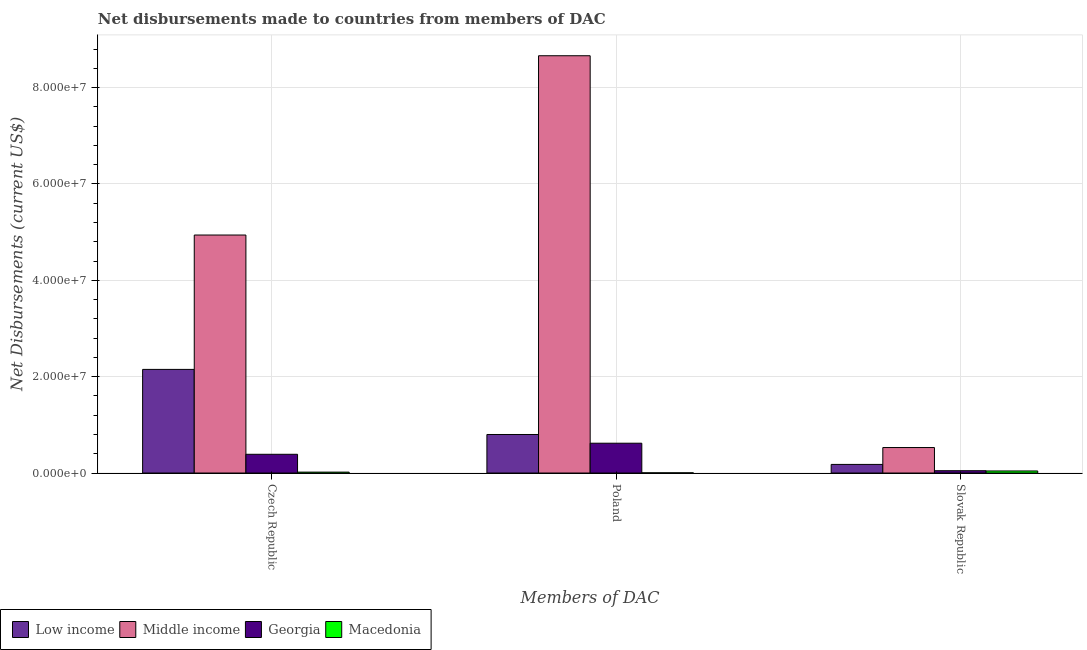How many different coloured bars are there?
Provide a succinct answer. 4. How many groups of bars are there?
Make the answer very short. 3. Are the number of bars per tick equal to the number of legend labels?
Provide a short and direct response. Yes. How many bars are there on the 2nd tick from the right?
Your answer should be compact. 4. What is the label of the 2nd group of bars from the left?
Offer a very short reply. Poland. What is the net disbursements made by poland in Low income?
Offer a very short reply. 8.00e+06. Across all countries, what is the maximum net disbursements made by slovak republic?
Offer a very short reply. 5.29e+06. Across all countries, what is the minimum net disbursements made by slovak republic?
Offer a terse response. 4.30e+05. In which country was the net disbursements made by czech republic maximum?
Offer a very short reply. Middle income. In which country was the net disbursements made by czech republic minimum?
Offer a very short reply. Macedonia. What is the total net disbursements made by slovak republic in the graph?
Keep it short and to the point. 7.99e+06. What is the difference between the net disbursements made by czech republic in Middle income and that in Low income?
Provide a short and direct response. 2.79e+07. What is the difference between the net disbursements made by czech republic in Low income and the net disbursements made by slovak republic in Georgia?
Your answer should be very brief. 2.10e+07. What is the average net disbursements made by slovak republic per country?
Ensure brevity in your answer.  2.00e+06. What is the difference between the net disbursements made by poland and net disbursements made by czech republic in Low income?
Your response must be concise. -1.35e+07. What is the ratio of the net disbursements made by poland in Low income to that in Middle income?
Your answer should be compact. 0.09. Is the net disbursements made by czech republic in Middle income less than that in Macedonia?
Ensure brevity in your answer.  No. Is the difference between the net disbursements made by poland in Middle income and Macedonia greater than the difference between the net disbursements made by czech republic in Middle income and Macedonia?
Offer a very short reply. Yes. What is the difference between the highest and the second highest net disbursements made by slovak republic?
Keep it short and to the point. 3.50e+06. What is the difference between the highest and the lowest net disbursements made by slovak republic?
Offer a terse response. 4.86e+06. In how many countries, is the net disbursements made by slovak republic greater than the average net disbursements made by slovak republic taken over all countries?
Your answer should be compact. 1. Is the sum of the net disbursements made by poland in Middle income and Macedonia greater than the maximum net disbursements made by czech republic across all countries?
Offer a very short reply. Yes. What does the 4th bar from the left in Czech Republic represents?
Keep it short and to the point. Macedonia. What does the 3rd bar from the right in Poland represents?
Offer a terse response. Middle income. What is the difference between two consecutive major ticks on the Y-axis?
Your response must be concise. 2.00e+07. Are the values on the major ticks of Y-axis written in scientific E-notation?
Your response must be concise. Yes. Does the graph contain grids?
Make the answer very short. Yes. How are the legend labels stacked?
Your response must be concise. Horizontal. What is the title of the graph?
Keep it short and to the point. Net disbursements made to countries from members of DAC. Does "Lao PDR" appear as one of the legend labels in the graph?
Ensure brevity in your answer.  No. What is the label or title of the X-axis?
Make the answer very short. Members of DAC. What is the label or title of the Y-axis?
Make the answer very short. Net Disbursements (current US$). What is the Net Disbursements (current US$) in Low income in Czech Republic?
Make the answer very short. 2.15e+07. What is the Net Disbursements (current US$) in Middle income in Czech Republic?
Offer a terse response. 4.94e+07. What is the Net Disbursements (current US$) in Georgia in Czech Republic?
Give a very brief answer. 3.89e+06. What is the Net Disbursements (current US$) of Macedonia in Czech Republic?
Give a very brief answer. 1.90e+05. What is the Net Disbursements (current US$) in Middle income in Poland?
Your response must be concise. 8.66e+07. What is the Net Disbursements (current US$) of Georgia in Poland?
Your answer should be very brief. 6.19e+06. What is the Net Disbursements (current US$) of Low income in Slovak Republic?
Give a very brief answer. 1.79e+06. What is the Net Disbursements (current US$) of Middle income in Slovak Republic?
Offer a very short reply. 5.29e+06. Across all Members of DAC, what is the maximum Net Disbursements (current US$) of Low income?
Offer a very short reply. 2.15e+07. Across all Members of DAC, what is the maximum Net Disbursements (current US$) in Middle income?
Keep it short and to the point. 8.66e+07. Across all Members of DAC, what is the maximum Net Disbursements (current US$) of Georgia?
Provide a succinct answer. 6.19e+06. Across all Members of DAC, what is the minimum Net Disbursements (current US$) of Low income?
Your response must be concise. 1.79e+06. Across all Members of DAC, what is the minimum Net Disbursements (current US$) in Middle income?
Your response must be concise. 5.29e+06. What is the total Net Disbursements (current US$) in Low income in the graph?
Offer a terse response. 3.13e+07. What is the total Net Disbursements (current US$) of Middle income in the graph?
Keep it short and to the point. 1.41e+08. What is the total Net Disbursements (current US$) of Georgia in the graph?
Keep it short and to the point. 1.06e+07. What is the difference between the Net Disbursements (current US$) in Low income in Czech Republic and that in Poland?
Offer a very short reply. 1.35e+07. What is the difference between the Net Disbursements (current US$) in Middle income in Czech Republic and that in Poland?
Ensure brevity in your answer.  -3.72e+07. What is the difference between the Net Disbursements (current US$) of Georgia in Czech Republic and that in Poland?
Offer a terse response. -2.30e+06. What is the difference between the Net Disbursements (current US$) in Macedonia in Czech Republic and that in Poland?
Your response must be concise. 1.50e+05. What is the difference between the Net Disbursements (current US$) of Low income in Czech Republic and that in Slovak Republic?
Your answer should be compact. 1.97e+07. What is the difference between the Net Disbursements (current US$) of Middle income in Czech Republic and that in Slovak Republic?
Ensure brevity in your answer.  4.41e+07. What is the difference between the Net Disbursements (current US$) in Georgia in Czech Republic and that in Slovak Republic?
Your answer should be compact. 3.41e+06. What is the difference between the Net Disbursements (current US$) in Macedonia in Czech Republic and that in Slovak Republic?
Provide a short and direct response. -2.40e+05. What is the difference between the Net Disbursements (current US$) in Low income in Poland and that in Slovak Republic?
Provide a short and direct response. 6.21e+06. What is the difference between the Net Disbursements (current US$) of Middle income in Poland and that in Slovak Republic?
Offer a very short reply. 8.13e+07. What is the difference between the Net Disbursements (current US$) of Georgia in Poland and that in Slovak Republic?
Give a very brief answer. 5.71e+06. What is the difference between the Net Disbursements (current US$) of Macedonia in Poland and that in Slovak Republic?
Give a very brief answer. -3.90e+05. What is the difference between the Net Disbursements (current US$) of Low income in Czech Republic and the Net Disbursements (current US$) of Middle income in Poland?
Offer a very short reply. -6.51e+07. What is the difference between the Net Disbursements (current US$) in Low income in Czech Republic and the Net Disbursements (current US$) in Georgia in Poland?
Give a very brief answer. 1.53e+07. What is the difference between the Net Disbursements (current US$) in Low income in Czech Republic and the Net Disbursements (current US$) in Macedonia in Poland?
Offer a very short reply. 2.15e+07. What is the difference between the Net Disbursements (current US$) of Middle income in Czech Republic and the Net Disbursements (current US$) of Georgia in Poland?
Your answer should be very brief. 4.32e+07. What is the difference between the Net Disbursements (current US$) of Middle income in Czech Republic and the Net Disbursements (current US$) of Macedonia in Poland?
Your response must be concise. 4.94e+07. What is the difference between the Net Disbursements (current US$) of Georgia in Czech Republic and the Net Disbursements (current US$) of Macedonia in Poland?
Offer a very short reply. 3.85e+06. What is the difference between the Net Disbursements (current US$) in Low income in Czech Republic and the Net Disbursements (current US$) in Middle income in Slovak Republic?
Make the answer very short. 1.62e+07. What is the difference between the Net Disbursements (current US$) of Low income in Czech Republic and the Net Disbursements (current US$) of Georgia in Slovak Republic?
Offer a very short reply. 2.10e+07. What is the difference between the Net Disbursements (current US$) of Low income in Czech Republic and the Net Disbursements (current US$) of Macedonia in Slovak Republic?
Ensure brevity in your answer.  2.11e+07. What is the difference between the Net Disbursements (current US$) of Middle income in Czech Republic and the Net Disbursements (current US$) of Georgia in Slovak Republic?
Give a very brief answer. 4.89e+07. What is the difference between the Net Disbursements (current US$) of Middle income in Czech Republic and the Net Disbursements (current US$) of Macedonia in Slovak Republic?
Make the answer very short. 4.90e+07. What is the difference between the Net Disbursements (current US$) of Georgia in Czech Republic and the Net Disbursements (current US$) of Macedonia in Slovak Republic?
Offer a very short reply. 3.46e+06. What is the difference between the Net Disbursements (current US$) of Low income in Poland and the Net Disbursements (current US$) of Middle income in Slovak Republic?
Provide a succinct answer. 2.71e+06. What is the difference between the Net Disbursements (current US$) of Low income in Poland and the Net Disbursements (current US$) of Georgia in Slovak Republic?
Offer a very short reply. 7.52e+06. What is the difference between the Net Disbursements (current US$) in Low income in Poland and the Net Disbursements (current US$) in Macedonia in Slovak Republic?
Ensure brevity in your answer.  7.57e+06. What is the difference between the Net Disbursements (current US$) of Middle income in Poland and the Net Disbursements (current US$) of Georgia in Slovak Republic?
Give a very brief answer. 8.61e+07. What is the difference between the Net Disbursements (current US$) in Middle income in Poland and the Net Disbursements (current US$) in Macedonia in Slovak Republic?
Provide a succinct answer. 8.62e+07. What is the difference between the Net Disbursements (current US$) of Georgia in Poland and the Net Disbursements (current US$) of Macedonia in Slovak Republic?
Your response must be concise. 5.76e+06. What is the average Net Disbursements (current US$) of Low income per Members of DAC?
Your answer should be compact. 1.04e+07. What is the average Net Disbursements (current US$) in Middle income per Members of DAC?
Your answer should be compact. 4.71e+07. What is the average Net Disbursements (current US$) of Georgia per Members of DAC?
Your response must be concise. 3.52e+06. What is the difference between the Net Disbursements (current US$) in Low income and Net Disbursements (current US$) in Middle income in Czech Republic?
Give a very brief answer. -2.79e+07. What is the difference between the Net Disbursements (current US$) of Low income and Net Disbursements (current US$) of Georgia in Czech Republic?
Your answer should be compact. 1.76e+07. What is the difference between the Net Disbursements (current US$) in Low income and Net Disbursements (current US$) in Macedonia in Czech Republic?
Keep it short and to the point. 2.13e+07. What is the difference between the Net Disbursements (current US$) of Middle income and Net Disbursements (current US$) of Georgia in Czech Republic?
Your answer should be compact. 4.55e+07. What is the difference between the Net Disbursements (current US$) in Middle income and Net Disbursements (current US$) in Macedonia in Czech Republic?
Ensure brevity in your answer.  4.92e+07. What is the difference between the Net Disbursements (current US$) of Georgia and Net Disbursements (current US$) of Macedonia in Czech Republic?
Offer a very short reply. 3.70e+06. What is the difference between the Net Disbursements (current US$) in Low income and Net Disbursements (current US$) in Middle income in Poland?
Keep it short and to the point. -7.86e+07. What is the difference between the Net Disbursements (current US$) of Low income and Net Disbursements (current US$) of Georgia in Poland?
Your answer should be compact. 1.81e+06. What is the difference between the Net Disbursements (current US$) in Low income and Net Disbursements (current US$) in Macedonia in Poland?
Your answer should be compact. 7.96e+06. What is the difference between the Net Disbursements (current US$) in Middle income and Net Disbursements (current US$) in Georgia in Poland?
Give a very brief answer. 8.04e+07. What is the difference between the Net Disbursements (current US$) of Middle income and Net Disbursements (current US$) of Macedonia in Poland?
Ensure brevity in your answer.  8.66e+07. What is the difference between the Net Disbursements (current US$) of Georgia and Net Disbursements (current US$) of Macedonia in Poland?
Make the answer very short. 6.15e+06. What is the difference between the Net Disbursements (current US$) of Low income and Net Disbursements (current US$) of Middle income in Slovak Republic?
Provide a short and direct response. -3.50e+06. What is the difference between the Net Disbursements (current US$) of Low income and Net Disbursements (current US$) of Georgia in Slovak Republic?
Make the answer very short. 1.31e+06. What is the difference between the Net Disbursements (current US$) of Low income and Net Disbursements (current US$) of Macedonia in Slovak Republic?
Ensure brevity in your answer.  1.36e+06. What is the difference between the Net Disbursements (current US$) in Middle income and Net Disbursements (current US$) in Georgia in Slovak Republic?
Provide a short and direct response. 4.81e+06. What is the difference between the Net Disbursements (current US$) of Middle income and Net Disbursements (current US$) of Macedonia in Slovak Republic?
Offer a terse response. 4.86e+06. What is the difference between the Net Disbursements (current US$) in Georgia and Net Disbursements (current US$) in Macedonia in Slovak Republic?
Keep it short and to the point. 5.00e+04. What is the ratio of the Net Disbursements (current US$) in Low income in Czech Republic to that in Poland?
Offer a terse response. 2.69. What is the ratio of the Net Disbursements (current US$) in Middle income in Czech Republic to that in Poland?
Your answer should be very brief. 0.57. What is the ratio of the Net Disbursements (current US$) in Georgia in Czech Republic to that in Poland?
Give a very brief answer. 0.63. What is the ratio of the Net Disbursements (current US$) of Macedonia in Czech Republic to that in Poland?
Keep it short and to the point. 4.75. What is the ratio of the Net Disbursements (current US$) of Low income in Czech Republic to that in Slovak Republic?
Keep it short and to the point. 12.02. What is the ratio of the Net Disbursements (current US$) of Middle income in Czech Republic to that in Slovak Republic?
Give a very brief answer. 9.34. What is the ratio of the Net Disbursements (current US$) of Georgia in Czech Republic to that in Slovak Republic?
Give a very brief answer. 8.1. What is the ratio of the Net Disbursements (current US$) of Macedonia in Czech Republic to that in Slovak Republic?
Your response must be concise. 0.44. What is the ratio of the Net Disbursements (current US$) of Low income in Poland to that in Slovak Republic?
Your response must be concise. 4.47. What is the ratio of the Net Disbursements (current US$) in Middle income in Poland to that in Slovak Republic?
Keep it short and to the point. 16.37. What is the ratio of the Net Disbursements (current US$) in Georgia in Poland to that in Slovak Republic?
Give a very brief answer. 12.9. What is the ratio of the Net Disbursements (current US$) in Macedonia in Poland to that in Slovak Republic?
Make the answer very short. 0.09. What is the difference between the highest and the second highest Net Disbursements (current US$) of Low income?
Provide a short and direct response. 1.35e+07. What is the difference between the highest and the second highest Net Disbursements (current US$) in Middle income?
Give a very brief answer. 3.72e+07. What is the difference between the highest and the second highest Net Disbursements (current US$) of Georgia?
Make the answer very short. 2.30e+06. What is the difference between the highest and the lowest Net Disbursements (current US$) in Low income?
Your answer should be very brief. 1.97e+07. What is the difference between the highest and the lowest Net Disbursements (current US$) of Middle income?
Offer a terse response. 8.13e+07. What is the difference between the highest and the lowest Net Disbursements (current US$) in Georgia?
Your response must be concise. 5.71e+06. 